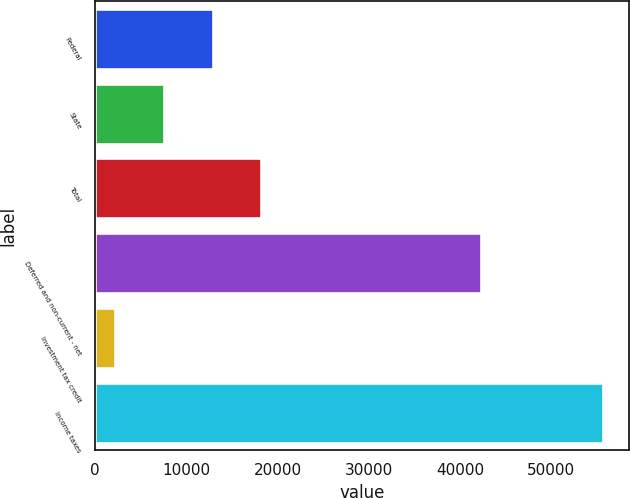Convert chart. <chart><loc_0><loc_0><loc_500><loc_500><bar_chart><fcel>Federal<fcel>State<fcel>Total<fcel>Deferred and non-current - net<fcel>Investment tax credit<fcel>Income taxes<nl><fcel>12879.6<fcel>7525.8<fcel>18233.4<fcel>42305<fcel>2172<fcel>55710<nl></chart> 